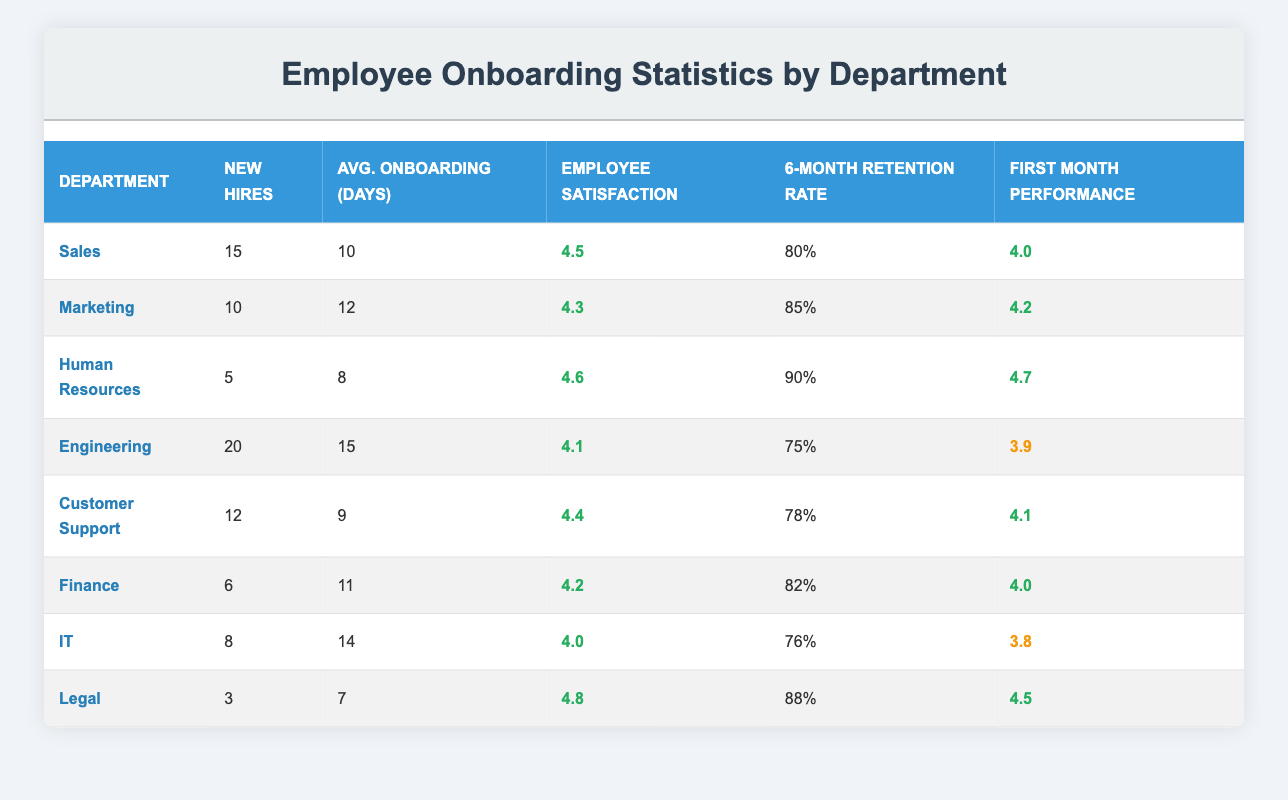What is the retention rate after 6 months for the Sales department? According to the table, the retention rate after 6 months for the Sales department is listed as 80%.
Answer: 80% Which department has the highest employee satisfaction rating? The Human Resources department has the highest employee satisfaction rating of 4.6.
Answer: 4.6 What is the average onboarding duration (in days) for all departments? To find the average onboarding duration, sum the days for all departments (10 + 12 + 8 + 15 + 9 + 11 + 14 + 7 = 86) and divide by the number of departments (8). So, 86/8 = 10.75 days.
Answer: 10.75 days Does the Engineering department have a first month performance rating above 4.0? The first month performance rating for Engineering is 3.9, which is not above 4.0, so the answer is false.
Answer: False How many new hires does the Customer Support department have compared to the IT department? The Customer Support department has 12 new hires, while the IT department has 8. Comparatively, Customer Support has 4 more hires than IT (12 - 8 = 4).
Answer: 4 more new hires What is the employee satisfaction rating for the Legal department? The employee satisfaction rating for the Legal department is 4.8 according to the table.
Answer: 4.8 Which department has the shortest average onboarding duration? The department with the shortest average onboarding duration is Legal at 7 days.
Answer: 7 days Is the retention rate after 6 months for the Marketing department above or below 80%? The retention rate for Marketing is 85%, which is above 80%, thus the answer is true.
Answer: True What is the combined number of new hires in the Finance and Legal departments? The Finance department has 6 new hires and the Legal department has 3 new hires, leading to a combined total of 9 new hires (6 + 3 = 9).
Answer: 9 new hires 